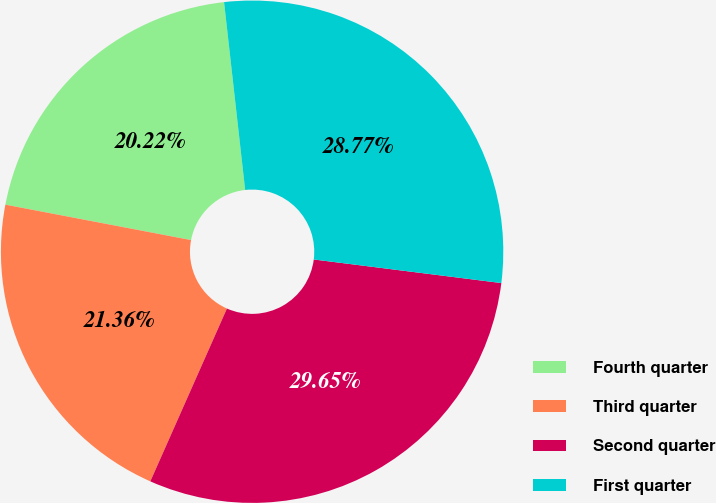Convert chart. <chart><loc_0><loc_0><loc_500><loc_500><pie_chart><fcel>Fourth quarter<fcel>Third quarter<fcel>Second quarter<fcel>First quarter<nl><fcel>20.22%<fcel>21.36%<fcel>29.65%<fcel>28.77%<nl></chart> 